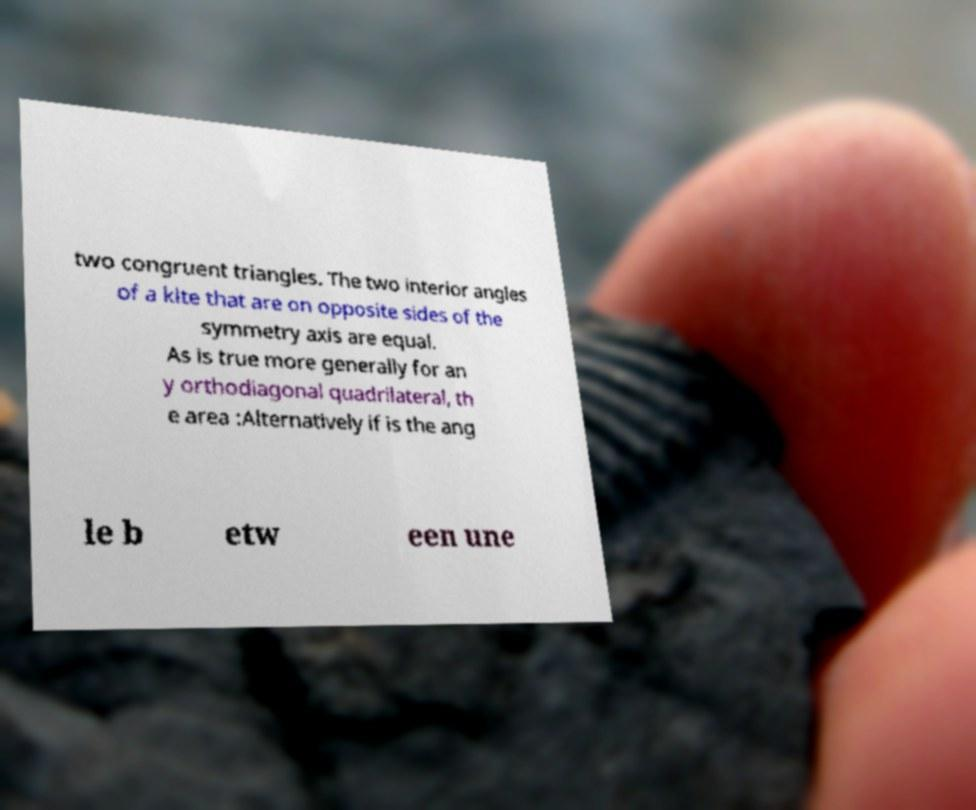For documentation purposes, I need the text within this image transcribed. Could you provide that? two congruent triangles. The two interior angles of a kite that are on opposite sides of the symmetry axis are equal. As is true more generally for an y orthodiagonal quadrilateral, th e area :Alternatively if is the ang le b etw een une 